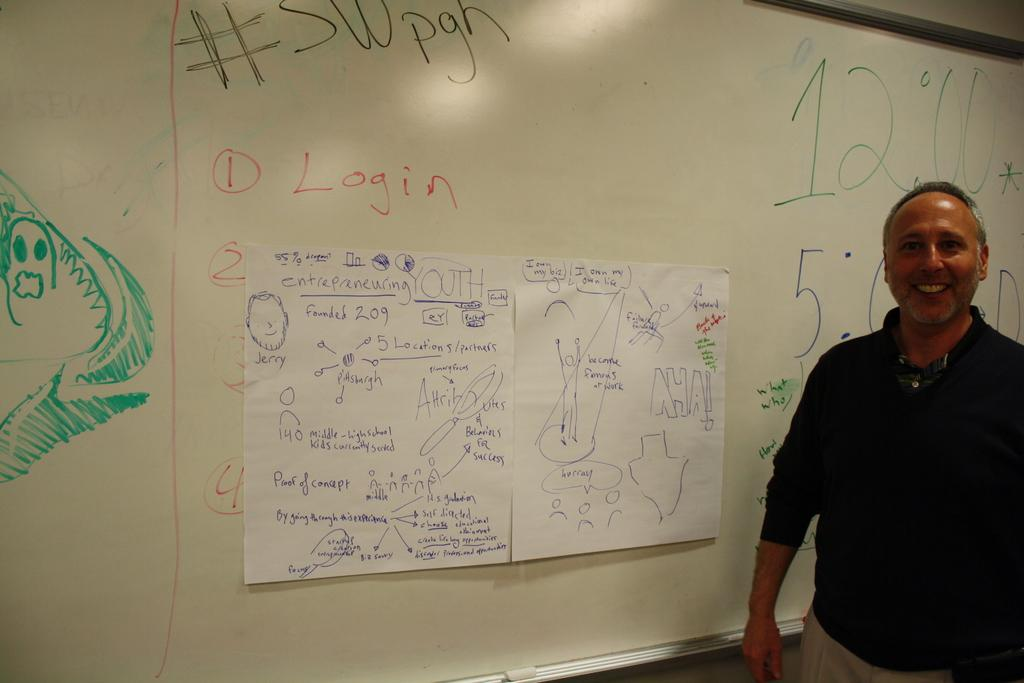<image>
Provide a brief description of the given image. Person standing in front of a board which says LOGIN at number 1. 